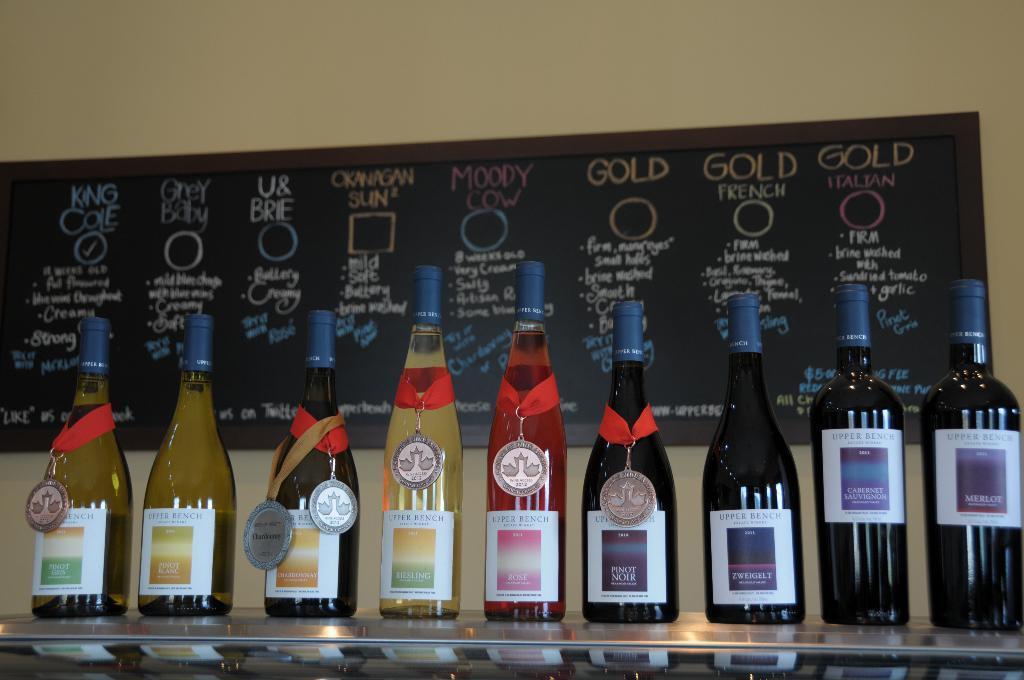Please provide a concise description of this image. In this image I can see few wine bottles are placed on the table. To the bottles I can see the medals. In the background a black color board is attached to the wall. On the board, I can see some text. 